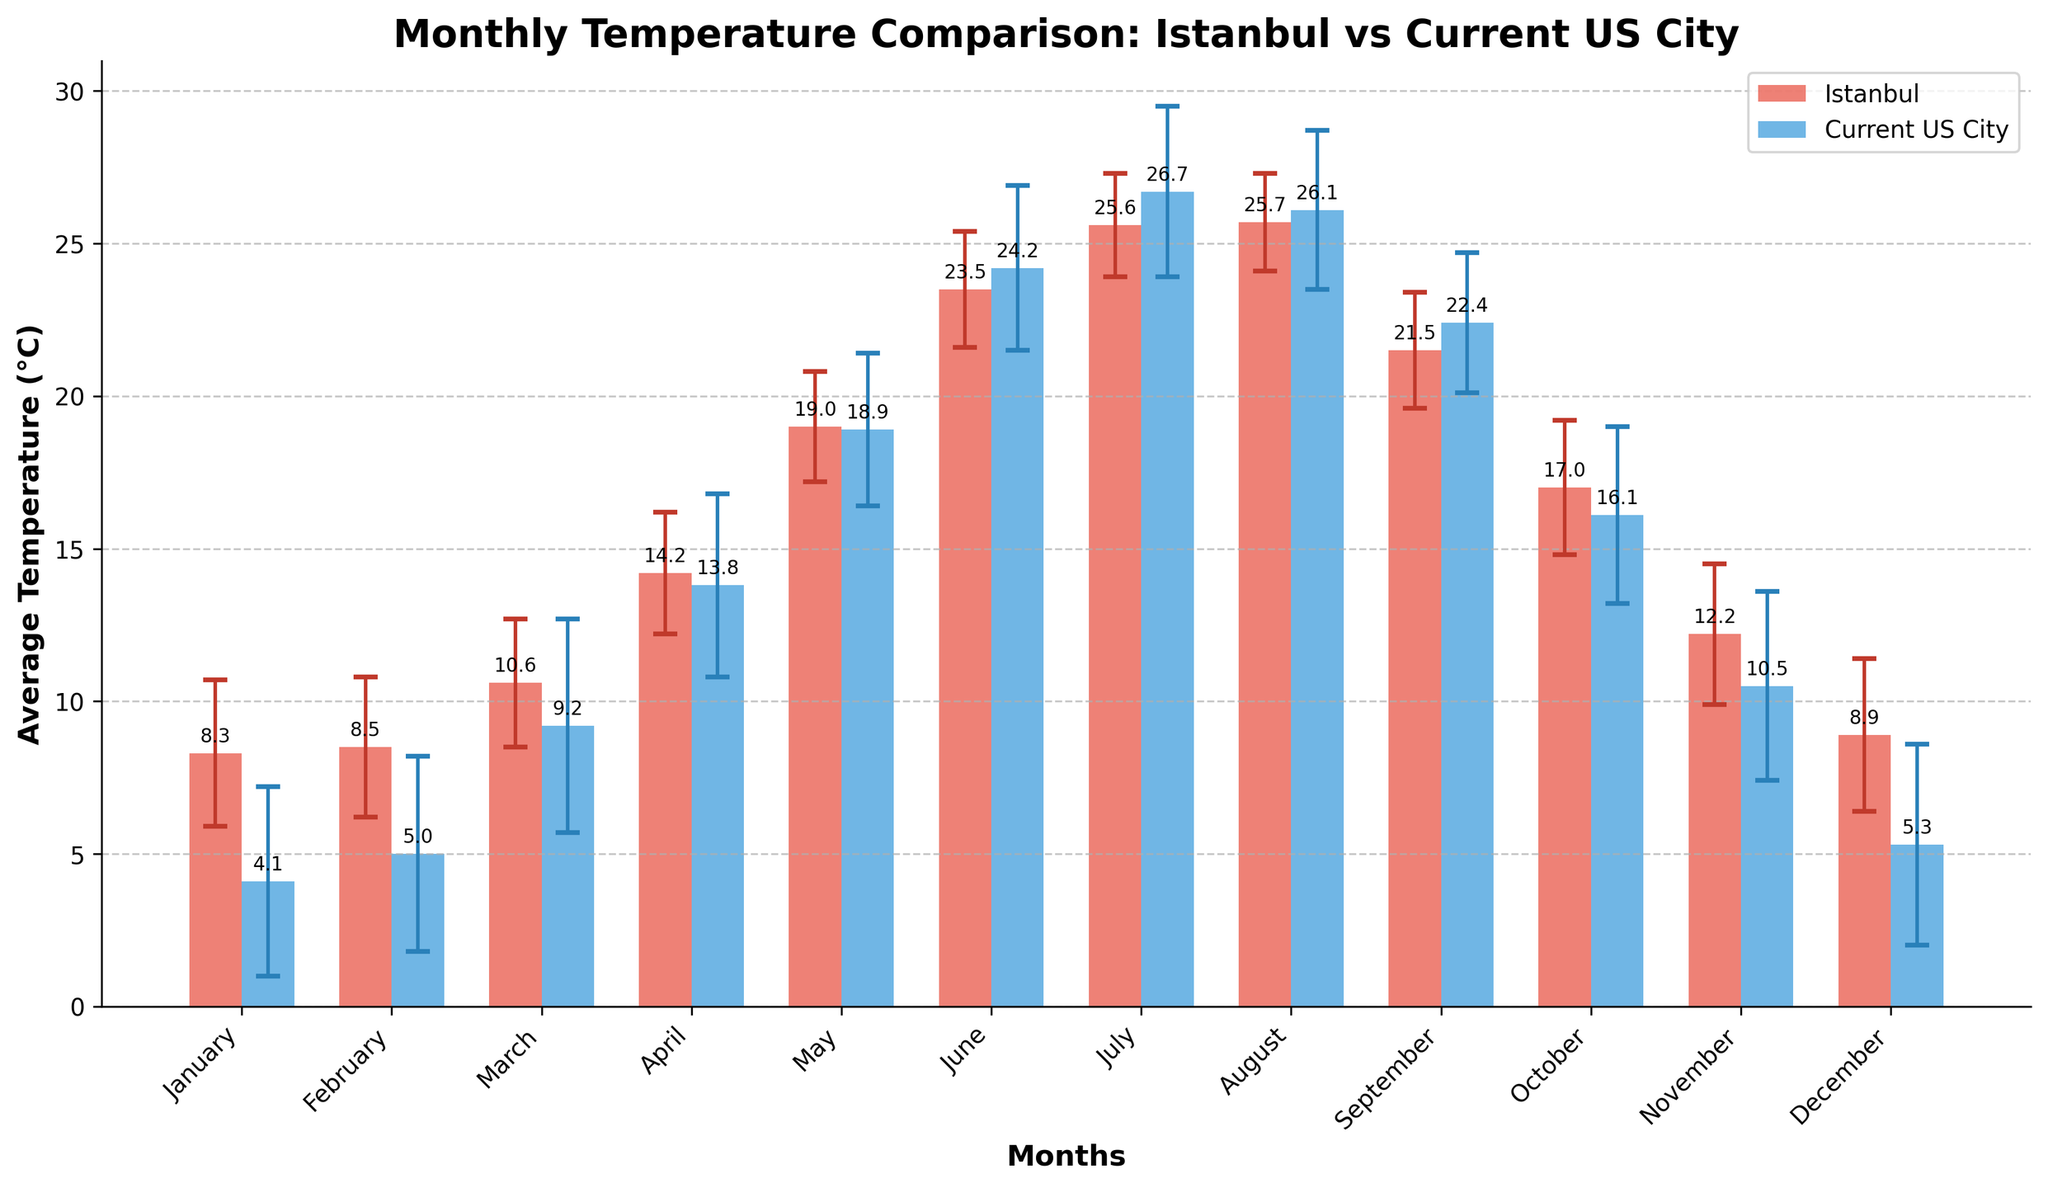What's the title of the figure? The title is located at the top of the figure. It summarizes the main topic of the plot. Reading the title, we can understand the subject of the visualization.
Answer: Monthly Temperature Comparison: Istanbul vs Current US City What is the average temperature in Istanbul in July? Look for the July bar in the Istanbul series and read the height, which represents the average temperature.
Answer: 25.6°C Which city has a higher average temperature in March, Istanbul, or the current US city? Identify the bars representing March for both Istanbul and the current US city, and compare their heights. Istanbul's average temperature in March is 10.6°C, while the current US city's is 9.2°C.
Answer: Istanbul What is the difference between the average temperatures of Istanbul and the current US city in January? Find the January bars for both Istanbul and the current US city, then subtract the current US city's average temperature from Istanbul's. 8.3°C - 4.1°C = 4.2°C.
Answer: 4.2°C During which month does the current US city have the highest average temperature? Identify the highest bar in the current US city's series and check the corresponding month. The highest bar is in July.
Answer: July What is the average temperature for the current US city in October, and what is its error margin? Locate the October bar for the current US city, read the height for the average temperature (16.1°C), and check the error bar's length to find the error margin (2.9°C).
Answer: 16.1°C, 2.9°C In which month is the temperature difference between Istanbul and the current US city the smallest? Calculate the difference between the average temperatures of the two cities for each month, then identify the month with the smallest difference. For example, in September:
Answer: 0.9°C Which city shows more stable temperatures throughout the year, as indicated by the standard deviations? Compare the lengths of the error bars for both cities across all months. Istanbul generally has shorter error bars, indicating more stable temperatures.
Answer: Istanbul What is the total average temperature for Istanbul over the year by summing monthly averages? Sum the average temperatures for Istanbul from January to December: 8.3 + 8.5 + 10.6 + 14.2 + 19.0 + 23.5 + 25.6 + 25.7 + 21.5 + 17.0 + 12.2 + 8.9 = 195.0°C.
Answer: 195.0°C 